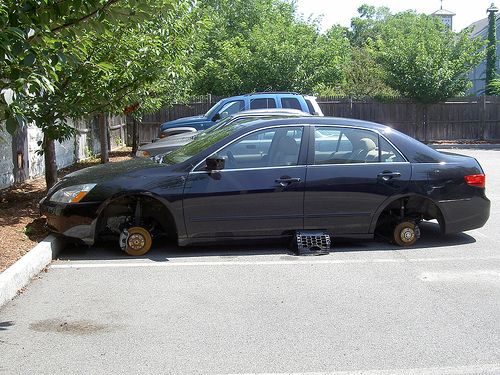<image>
Is there a basket under the car? Yes. The basket is positioned underneath the car, with the car above it in the vertical space. Is the jack under the car? Yes. The jack is positioned underneath the car, with the car above it in the vertical space. 